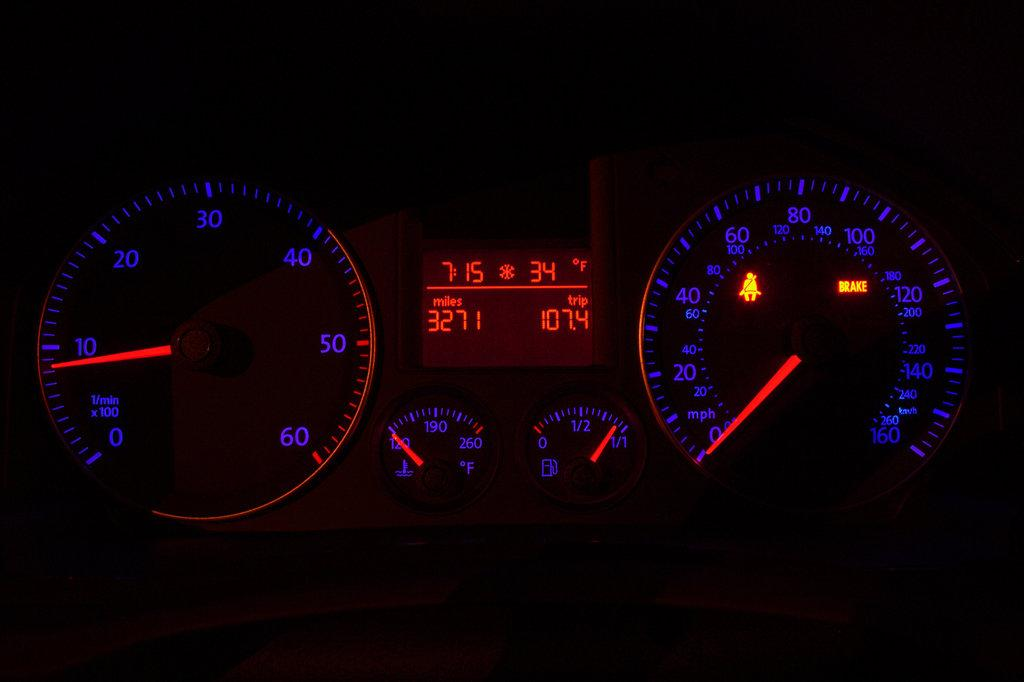What is the main subject of the image? The main subject of the image consists of speedometers. What color is the background of the image? The background of the image is black. How many dinosaurs can be seen flying in the image? There are no dinosaurs or flying objects present in the image; it consists solely of speedometers against a black background. 